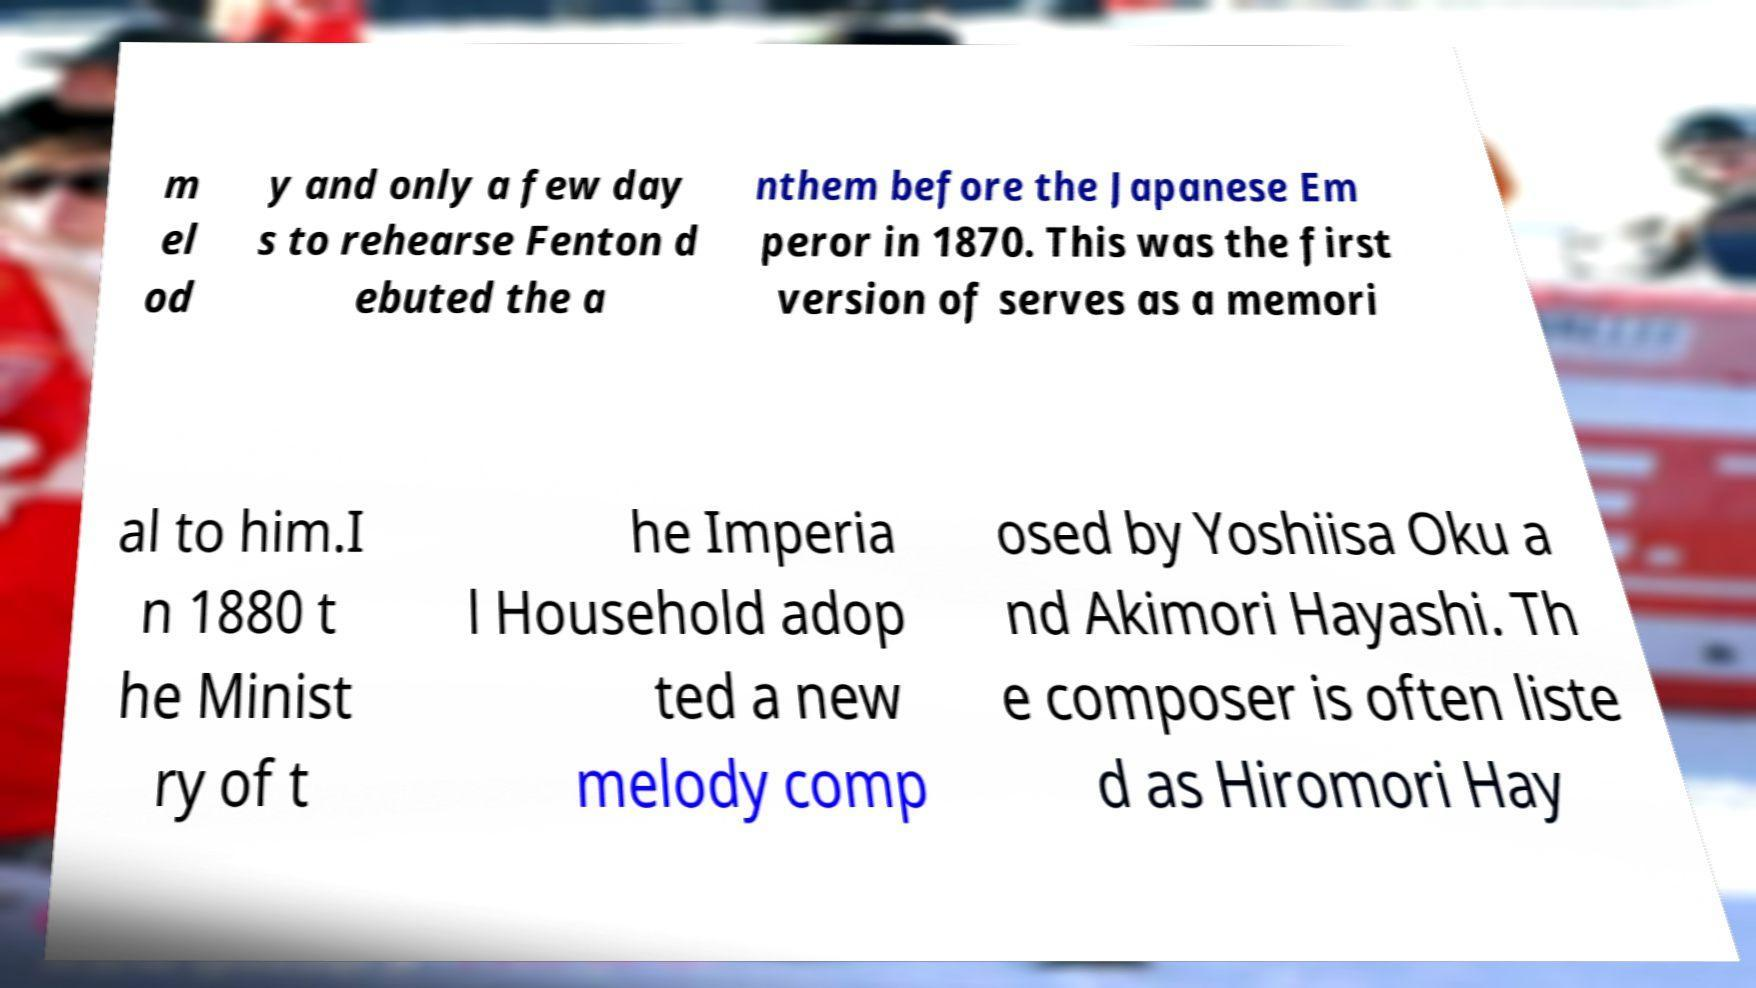There's text embedded in this image that I need extracted. Can you transcribe it verbatim? m el od y and only a few day s to rehearse Fenton d ebuted the a nthem before the Japanese Em peror in 1870. This was the first version of serves as a memori al to him.I n 1880 t he Minist ry of t he Imperia l Household adop ted a new melody comp osed by Yoshiisa Oku a nd Akimori Hayashi. Th e composer is often liste d as Hiromori Hay 